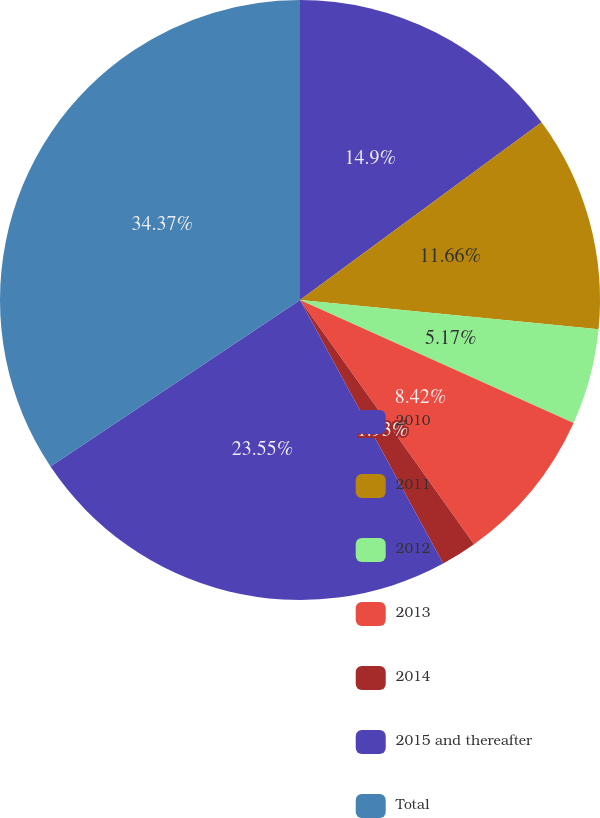<chart> <loc_0><loc_0><loc_500><loc_500><pie_chart><fcel>2010<fcel>2011<fcel>2012<fcel>2013<fcel>2014<fcel>2015 and thereafter<fcel>Total<nl><fcel>14.9%<fcel>11.66%<fcel>5.17%<fcel>8.42%<fcel>1.93%<fcel>23.55%<fcel>34.37%<nl></chart> 